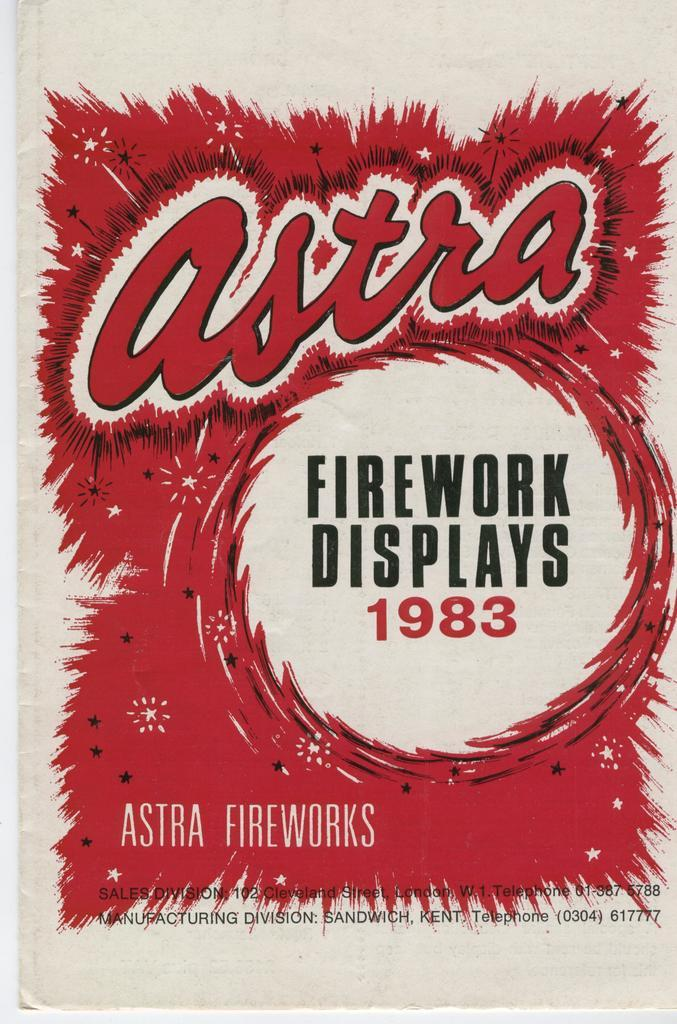<image>
Describe the image concisely. A poster that says Firework Displays 1983 with the brand Astra. 